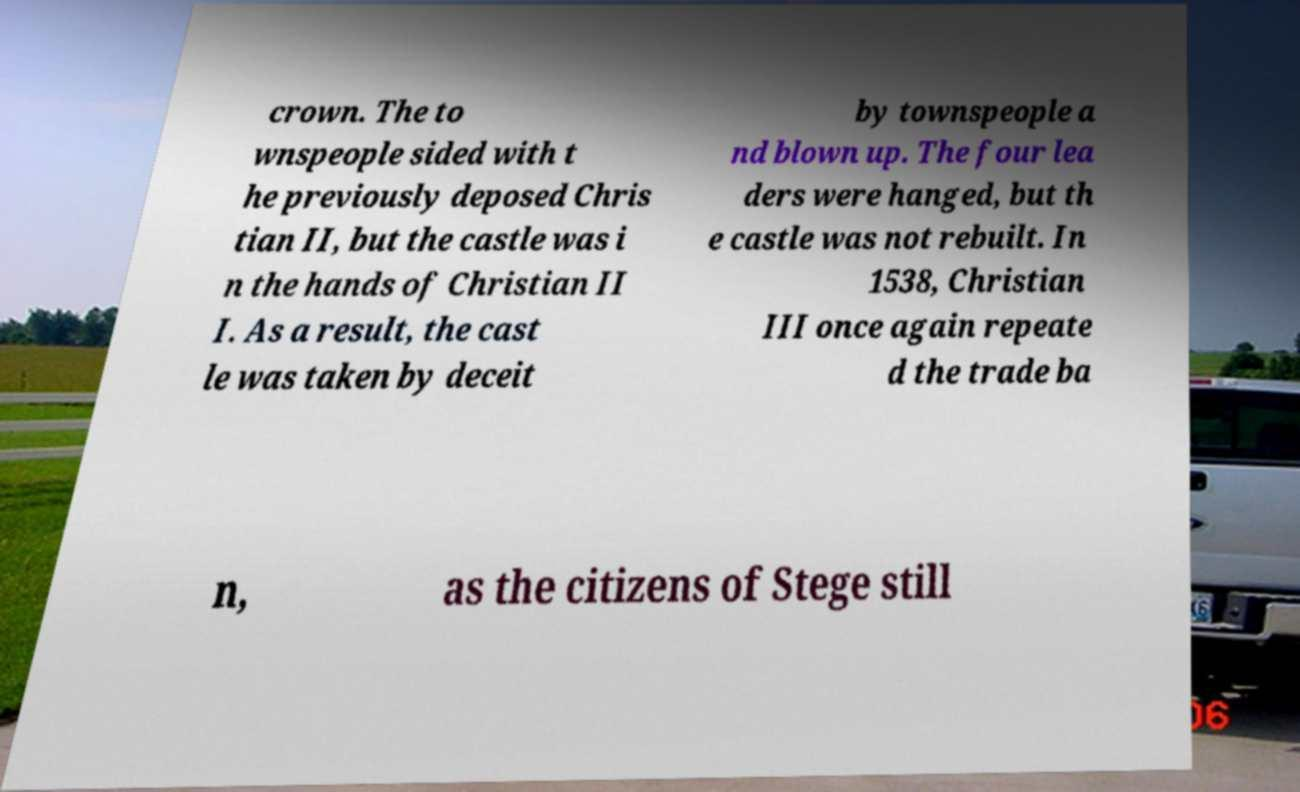Can you read and provide the text displayed in the image?This photo seems to have some interesting text. Can you extract and type it out for me? crown. The to wnspeople sided with t he previously deposed Chris tian II, but the castle was i n the hands of Christian II I. As a result, the cast le was taken by deceit by townspeople a nd blown up. The four lea ders were hanged, but th e castle was not rebuilt. In 1538, Christian III once again repeate d the trade ba n, as the citizens of Stege still 